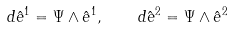<formula> <loc_0><loc_0><loc_500><loc_500>d { \hat { e } } ^ { 1 } = \Psi \wedge { \hat { e } } ^ { 1 } , \quad d { \hat { e } } ^ { 2 } = \Psi \wedge { \hat { e } } ^ { 2 }</formula> 